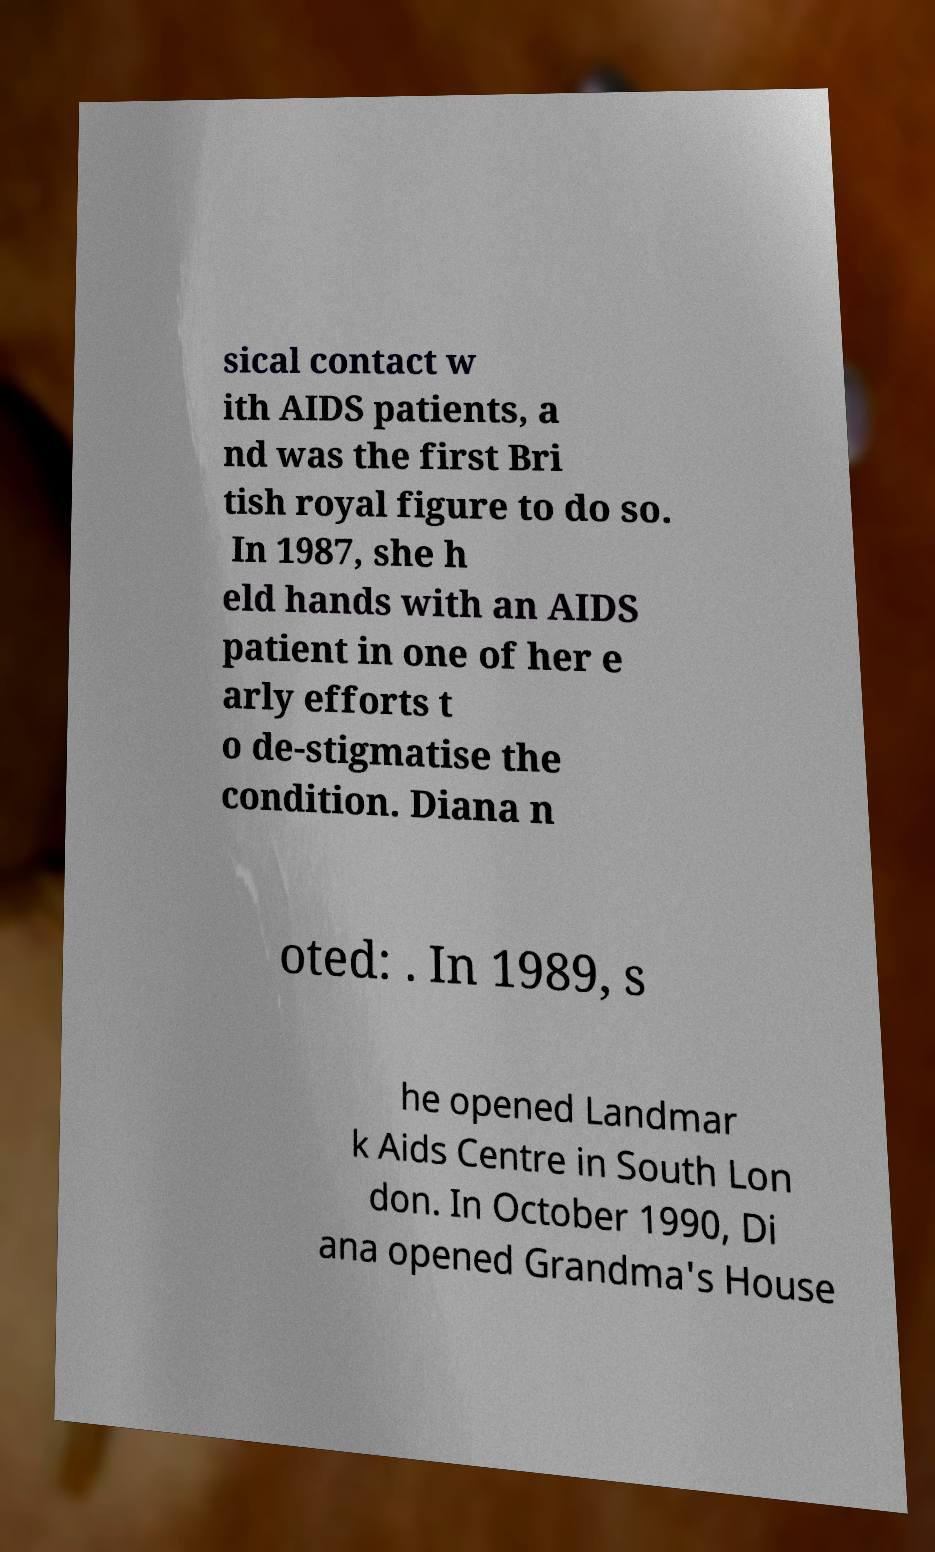There's text embedded in this image that I need extracted. Can you transcribe it verbatim? sical contact w ith AIDS patients, a nd was the first Bri tish royal figure to do so. In 1987, she h eld hands with an AIDS patient in one of her e arly efforts t o de-stigmatise the condition. Diana n oted: . In 1989, s he opened Landmar k Aids Centre in South Lon don. In October 1990, Di ana opened Grandma's House 